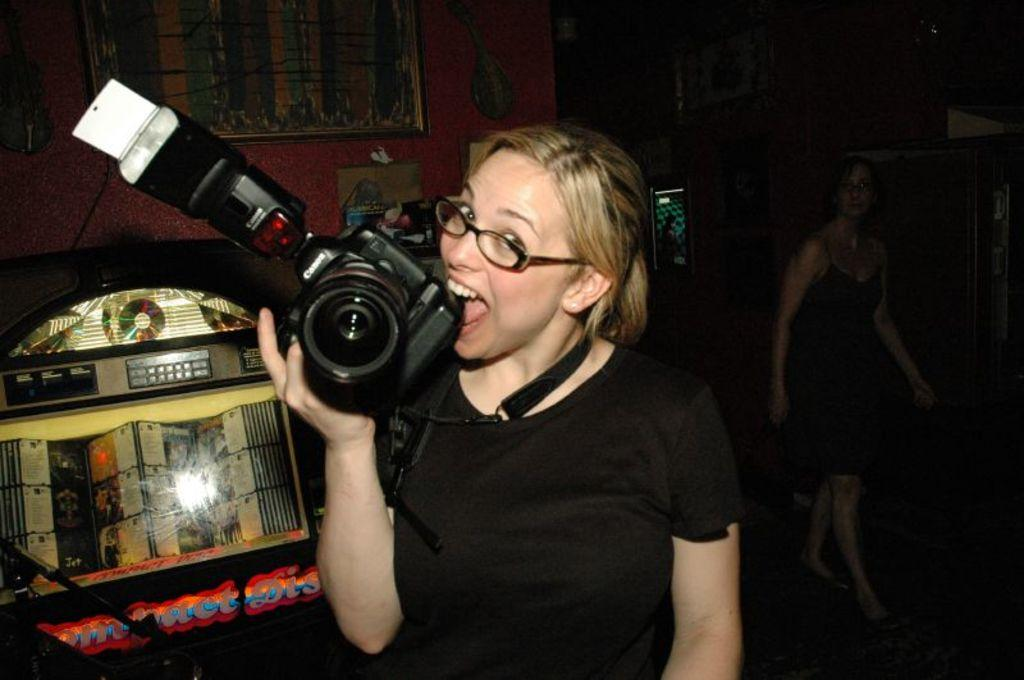What is the person in the image holding? The person is holding a camera. What position is the person in? The person is standing. What can be seen in the background of the image? There is a wall and a frame in the background. How many legs does the carriage have in the image? There is no carriage present in the image. What type of mine is visible in the background of the image? There is no mine present in the image. 